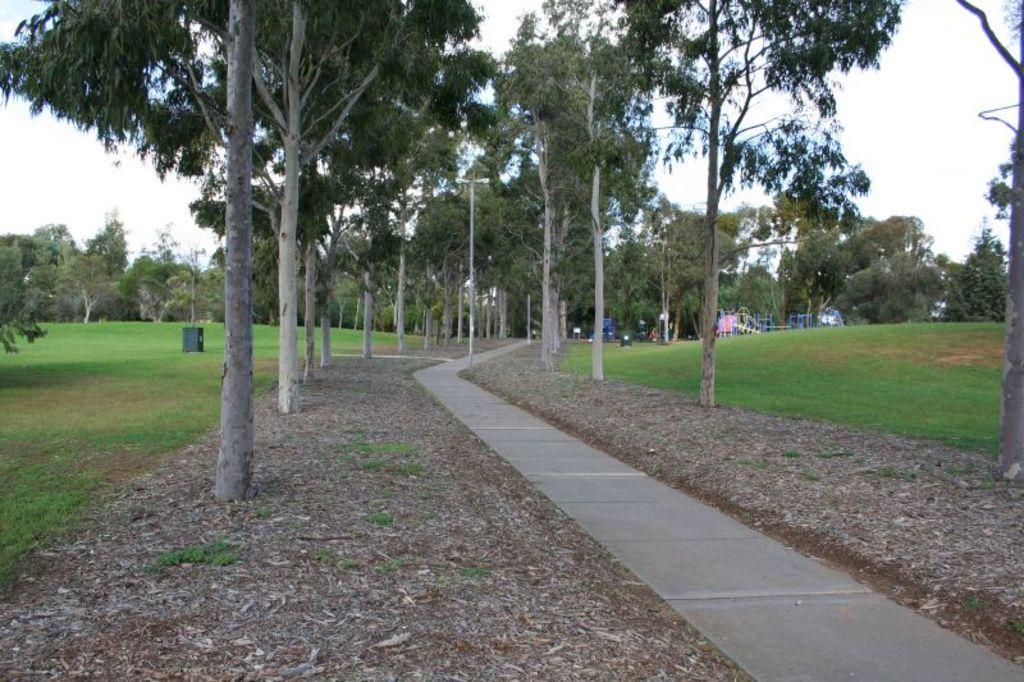Describe this image in one or two sentences. In the center of the image there is a road and the either sides of the road there are trees and grass. In the background of the image we can see there is a sky. 